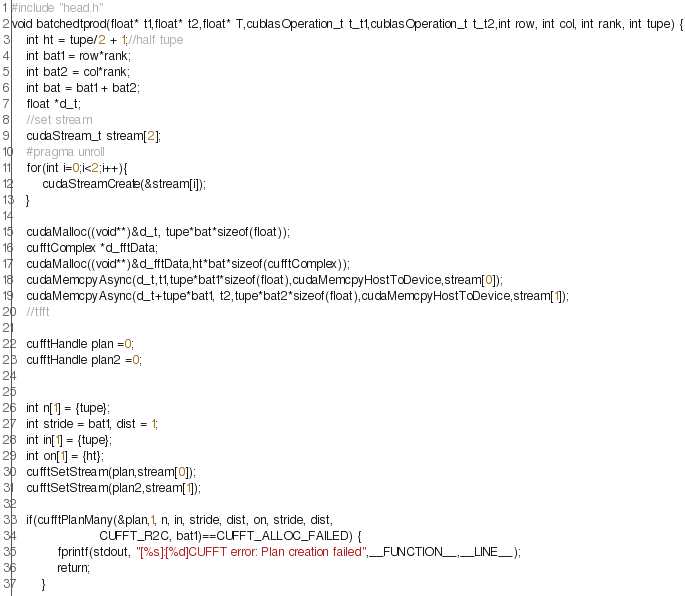<code> <loc_0><loc_0><loc_500><loc_500><_Cuda_>#include "head.h"
void batchedtprod(float* t1,float* t2,float* T,cublasOperation_t t_t1,cublasOperation_t t_t2,int row, int col, int rank, int tupe) {
    int ht = tupe/2 + 1;//half tupe
    int bat1 = row*rank;
    int bat2 = col*rank;
    int bat = bat1 + bat2;
    float *d_t;
    //set stream
    cudaStream_t stream[2];
    #pragma unroll
	for(int i=0;i<2;i++){
		cudaStreamCreate(&stream[i]);
	}
    
    cudaMalloc((void**)&d_t, tupe*bat*sizeof(float));
    cufftComplex *d_fftData;
    cudaMalloc((void**)&d_fftData,ht*bat*sizeof(cufftComplex));
    cudaMemcpyAsync(d_t,t1,tupe*bat1*sizeof(float),cudaMemcpyHostToDevice,stream[0]);
    cudaMemcpyAsync(d_t+tupe*bat1, t2,tupe*bat2*sizeof(float),cudaMemcpyHostToDevice,stream[1]);
    //tfft
   
    cufftHandle plan =0;
    cufftHandle plan2 =0;


    int n[1] = {tupe};
    int stride = bat1, dist = 1;
    int in[1] = {tupe};
    int on[1] = {ht};
    cufftSetStream(plan,stream[0]);
    cufftSetStream(plan2,stream[1]);
    
    if(cufftPlanMany(&plan,1, n, in, stride, dist, on, stride, dist,
                       CUFFT_R2C, bat1)==CUFFT_ALLOC_FAILED) {
            fprintf(stdout, "[%s]:[%d]CUFFT error: Plan creation failed",__FUNCTION__,__LINE__);
            return; 
        }</code> 